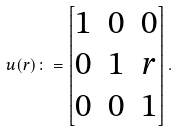Convert formula to latex. <formula><loc_0><loc_0><loc_500><loc_500>u ( r ) \colon = \begin{bmatrix} 1 & 0 & 0 \\ 0 & 1 & r \\ 0 & 0 & 1 \end{bmatrix} .</formula> 